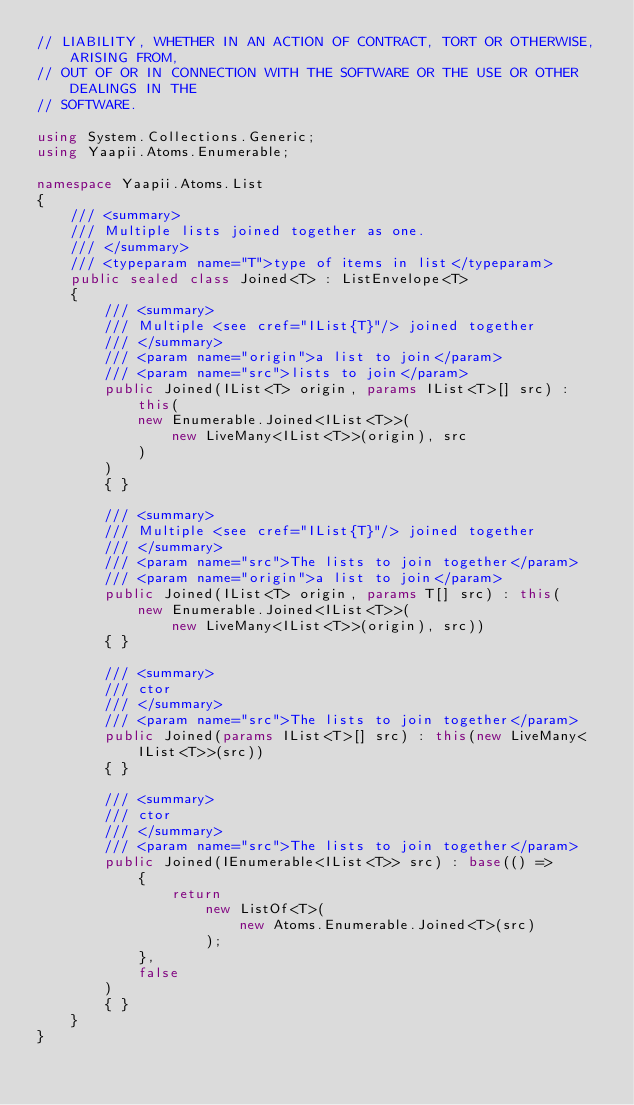<code> <loc_0><loc_0><loc_500><loc_500><_C#_>// LIABILITY, WHETHER IN AN ACTION OF CONTRACT, TORT OR OTHERWISE, ARISING FROM,
// OUT OF OR IN CONNECTION WITH THE SOFTWARE OR THE USE OR OTHER DEALINGS IN THE
// SOFTWARE.

using System.Collections.Generic;
using Yaapii.Atoms.Enumerable;

namespace Yaapii.Atoms.List
{
    /// <summary>
    /// Multiple lists joined together as one.
    /// </summary>
    /// <typeparam name="T">type of items in list</typeparam>
    public sealed class Joined<T> : ListEnvelope<T>
    {
        /// <summary>
        /// Multiple <see cref="IList{T}"/> joined together
        /// </summary>
        /// <param name="origin">a list to join</param>
        /// <param name="src">lists to join</param>
        public Joined(IList<T> origin, params IList<T>[] src) : this(
            new Enumerable.Joined<IList<T>>(
                new LiveMany<IList<T>>(origin), src
            )
        )
        { }

        /// <summary>
        /// Multiple <see cref="IList{T}"/> joined together
        /// </summary>
        /// <param name="src">The lists to join together</param>
        /// <param name="origin">a list to join</param>
        public Joined(IList<T> origin, params T[] src) : this(
            new Enumerable.Joined<IList<T>>(
                new LiveMany<IList<T>>(origin), src))
        { }

        /// <summary>
        /// ctor
        /// </summary>
        /// <param name="src">The lists to join together</param>
        public Joined(params IList<T>[] src) : this(new LiveMany<IList<T>>(src))
        { }

        /// <summary>
        /// ctor
        /// </summary>
        /// <param name="src">The lists to join together</param>
        public Joined(IEnumerable<IList<T>> src) : base(() =>
            {
                return
                    new ListOf<T>(
                        new Atoms.Enumerable.Joined<T>(src)
                    );
            },
            false
        )
        { }
    }
}
</code> 